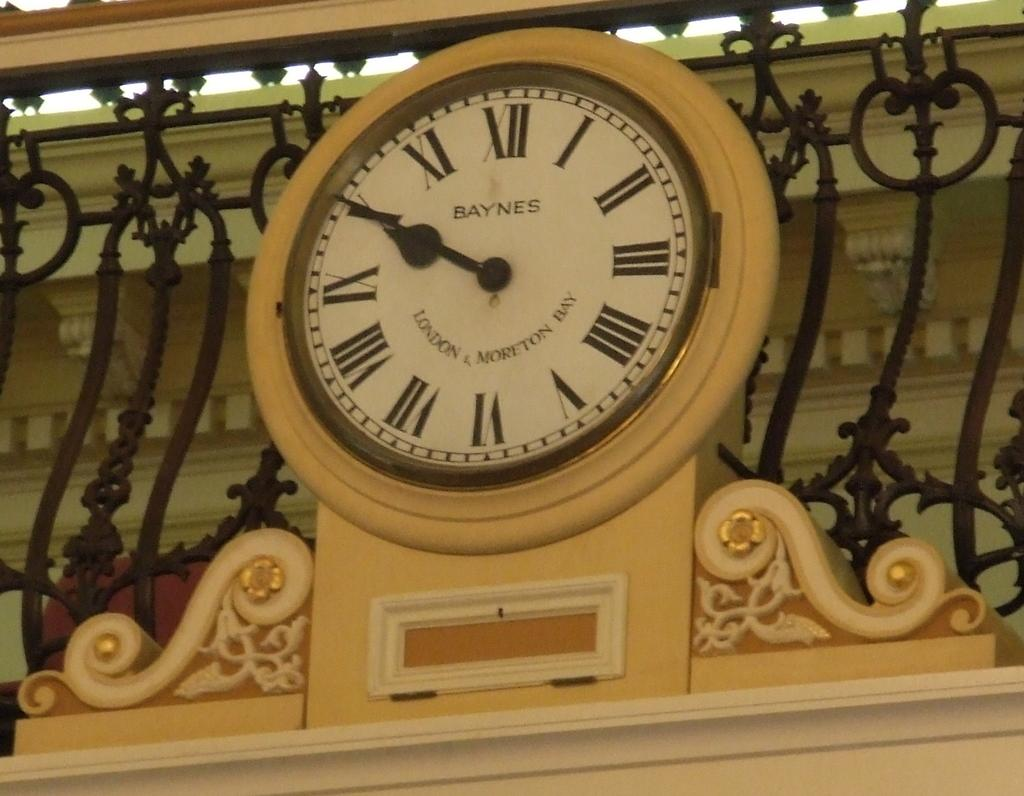Provide a one-sentence caption for the provided image. A decorative Baynes clock states the time as ten minutes till ten. 